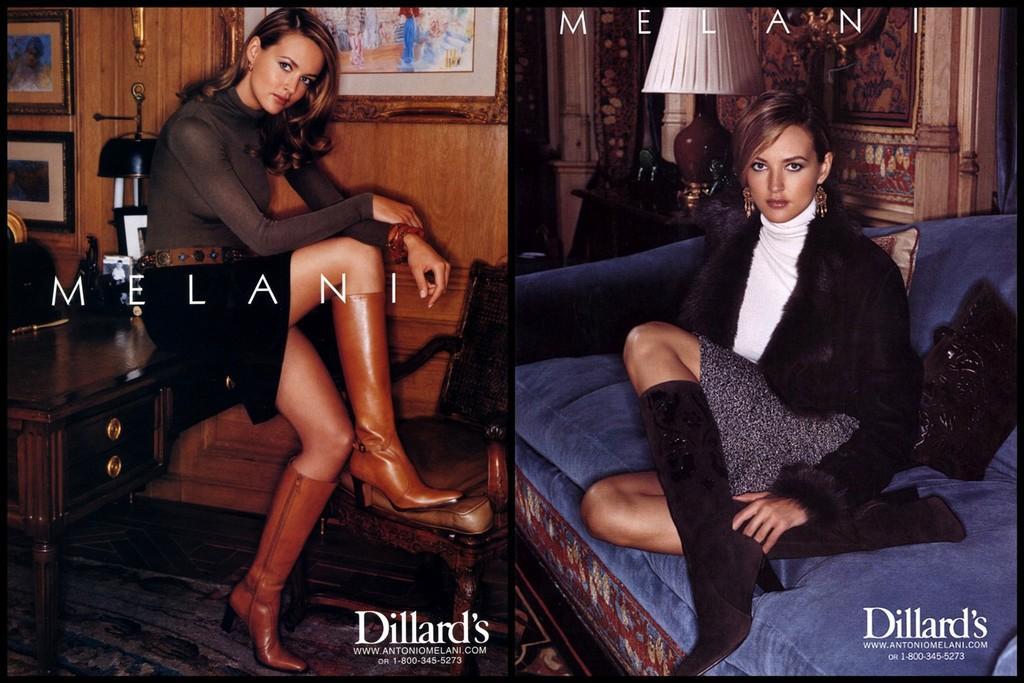Can you describe this image briefly? This is an edited collage image. In this image on the left side we can see a woman is sitting on a table and kept one of her leg on a chair and in the background there are frames on the wall and we can see photo frames and objects on the table. On the right side we can see a woman is sitting on a sofa and there are pillows on it and in the background we can see lamp and objects on a table and we can see objects on the wall. At the bottom we can see texts written on the images. 